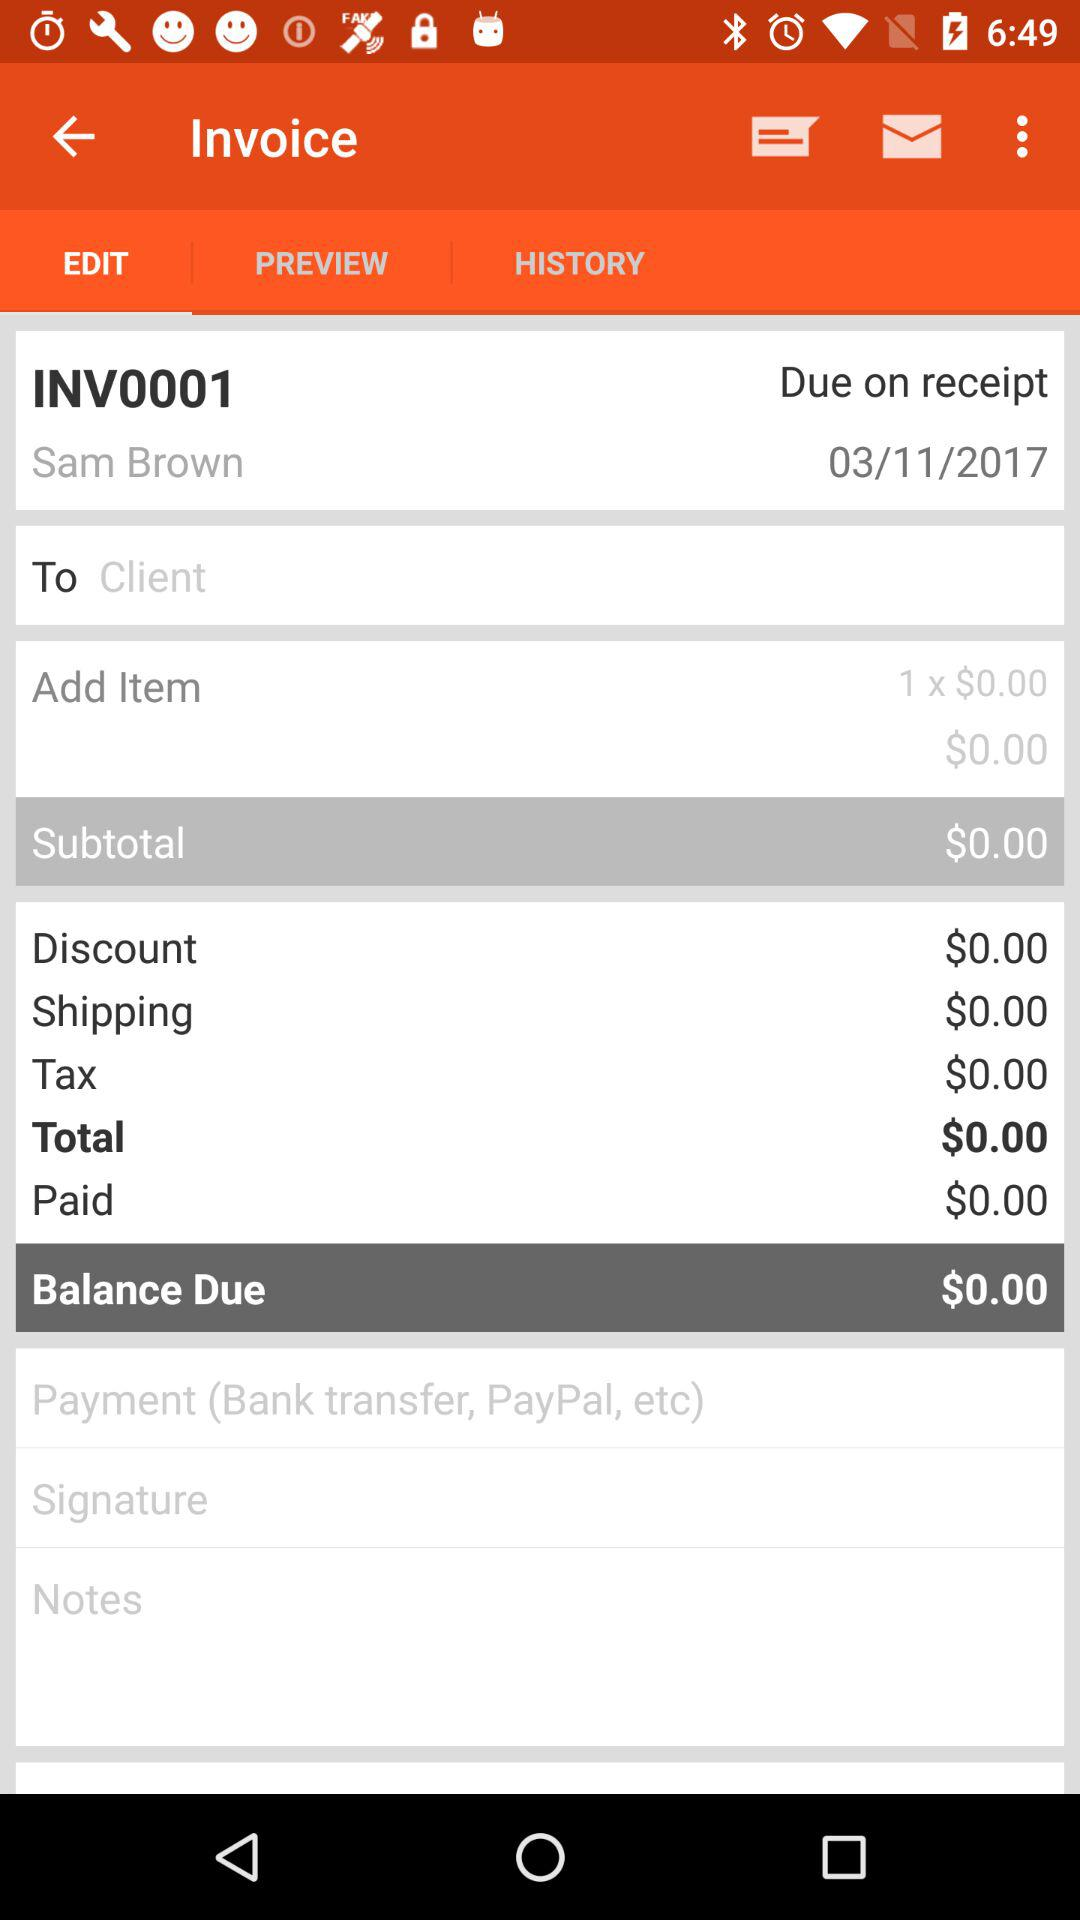How much balance is due? The due balance is $0.00. 